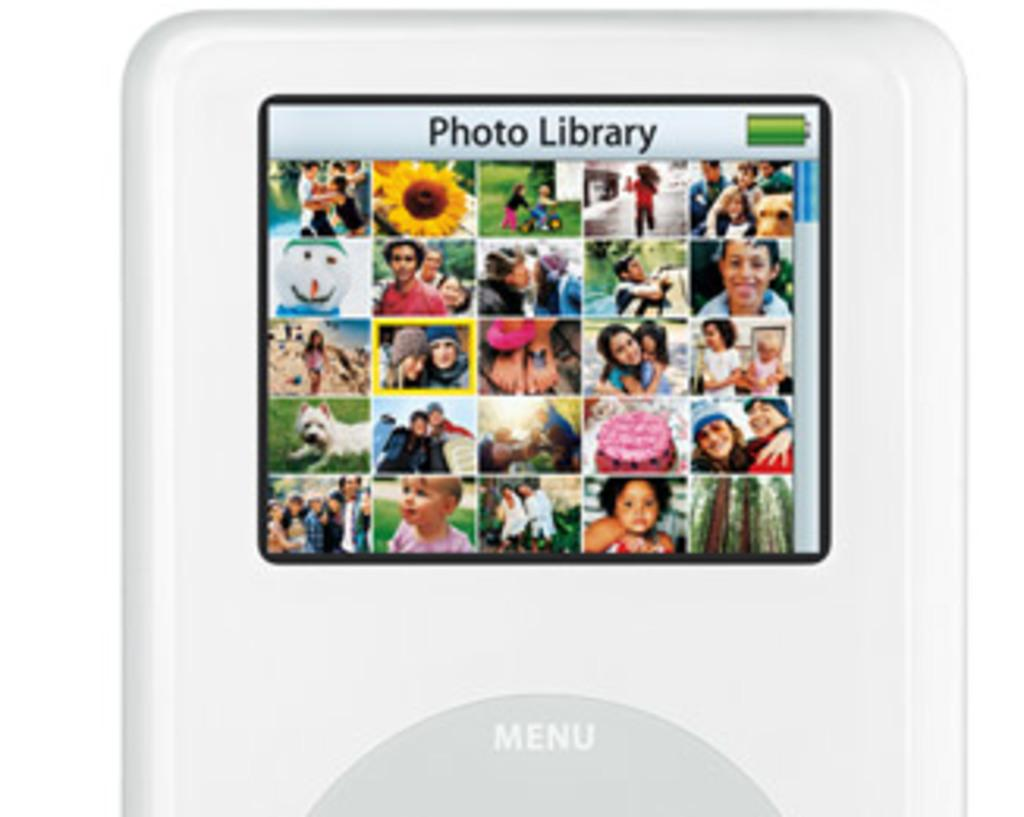What electronic device is visible in the image? There is an iPod in the image. What type of mark can be seen on the iPod in the image? There is no mark visible on the iPod in the image. What route is the iPod following in the image? The iPod is not following a route, as it is an electronic device and not a moving object. 